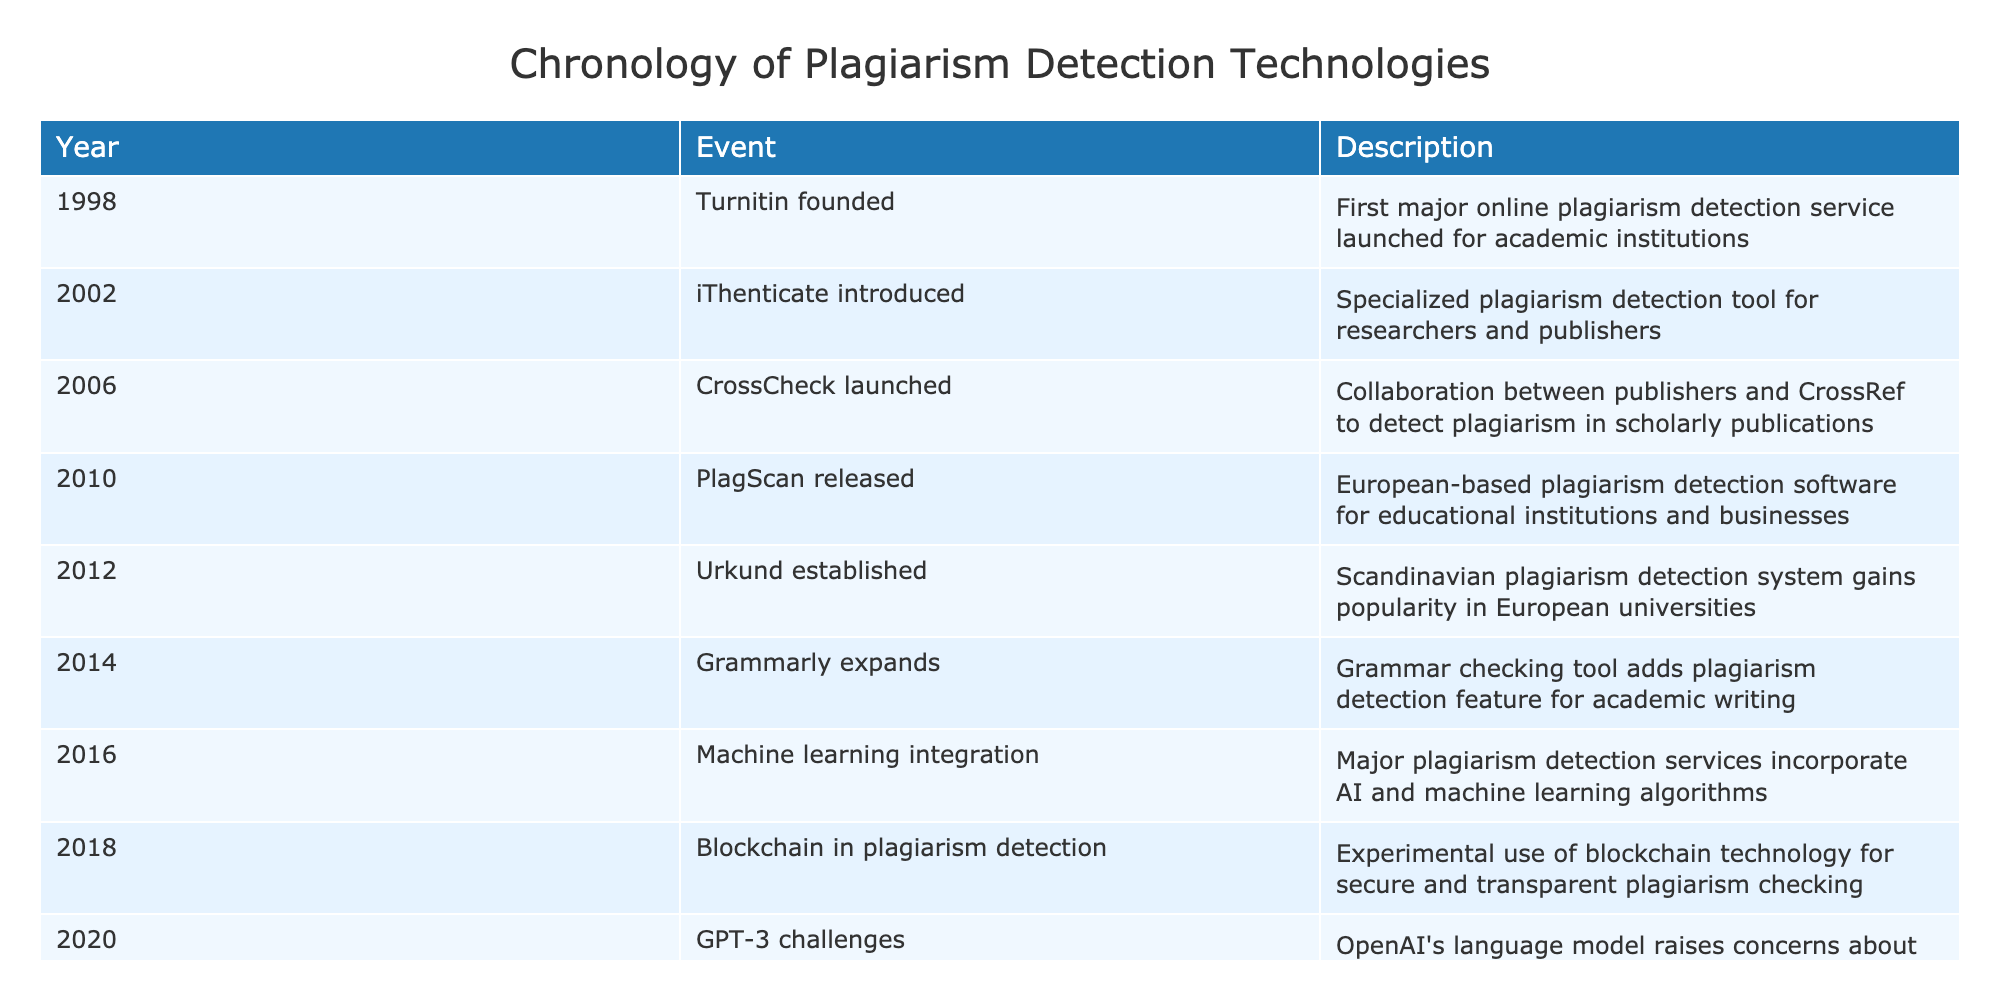What significant plagiarism detection tool was introduced in 2002? The table indicates that iThenticate, a specialized plagiarism detection tool for researchers and publishers, was introduced in 2002.
Answer: iThenticate Which year did Grammarly add a plagiarism detection feature? In the table, it is stated that Grammarly expanded its services to include a plagiarism detection feature in 2014.
Answer: 2014 How many years passed between the founding of Turnitin and the launch of CrossCheck? Turnitin was founded in 1998, and CrossCheck launched in 2006. The difference is 2006 - 1998 = 8 years.
Answer: 8 years Was there any mention of machine learning integration in plagiarism detection services? Yes, the table states that in 2016, major plagiarism detection services incorporated AI and machine learning algorithms.
Answer: Yes What event occurred in 2018, and how does it relate to previous technologies in the table? The event in 2018 was the experimental use of blockchain technology for secure and transparent plagiarism checking. This event shows a significant shift toward securing plagiarism detection methods, building on past technologies that focused more on text matching and algorithmic analysis.
Answer: Blockchain in plagiarism detection How many tools were launched or established between 2010 and 2016? From the table, we can identify four tools launched or established during this period: PlagScan (2010), Urkund (2012), Grammarly's expansion (2014), and machine learning integration (2016). Therefore, the total is four tools.
Answer: 4 tools Did CrossCheck focus on student plagiarism detection or scholarly publications? The table specifies that CrossCheck was launched to detect plagiarism in scholarly publications, not specifically targeting student work.
Answer: Scholarly publications Which advancements in plagiarism detection occurred after 2016, and what are their years? According to the table, the advancements after 2016 included blockchain in plagiarism detection (2018), challenges posed by GPT-3 (2020), and cross-language plagiarism detection (2022). Summarizing, the years are 2018, 2020, and 2022.
Answer: 2018, 2020, 2022 Which event marked the introduction of cross-language plagiarism detection? The introduction of cross-language plagiarism detection is marked by advancements made in the year 2022 according to the table.
Answer: 2022 